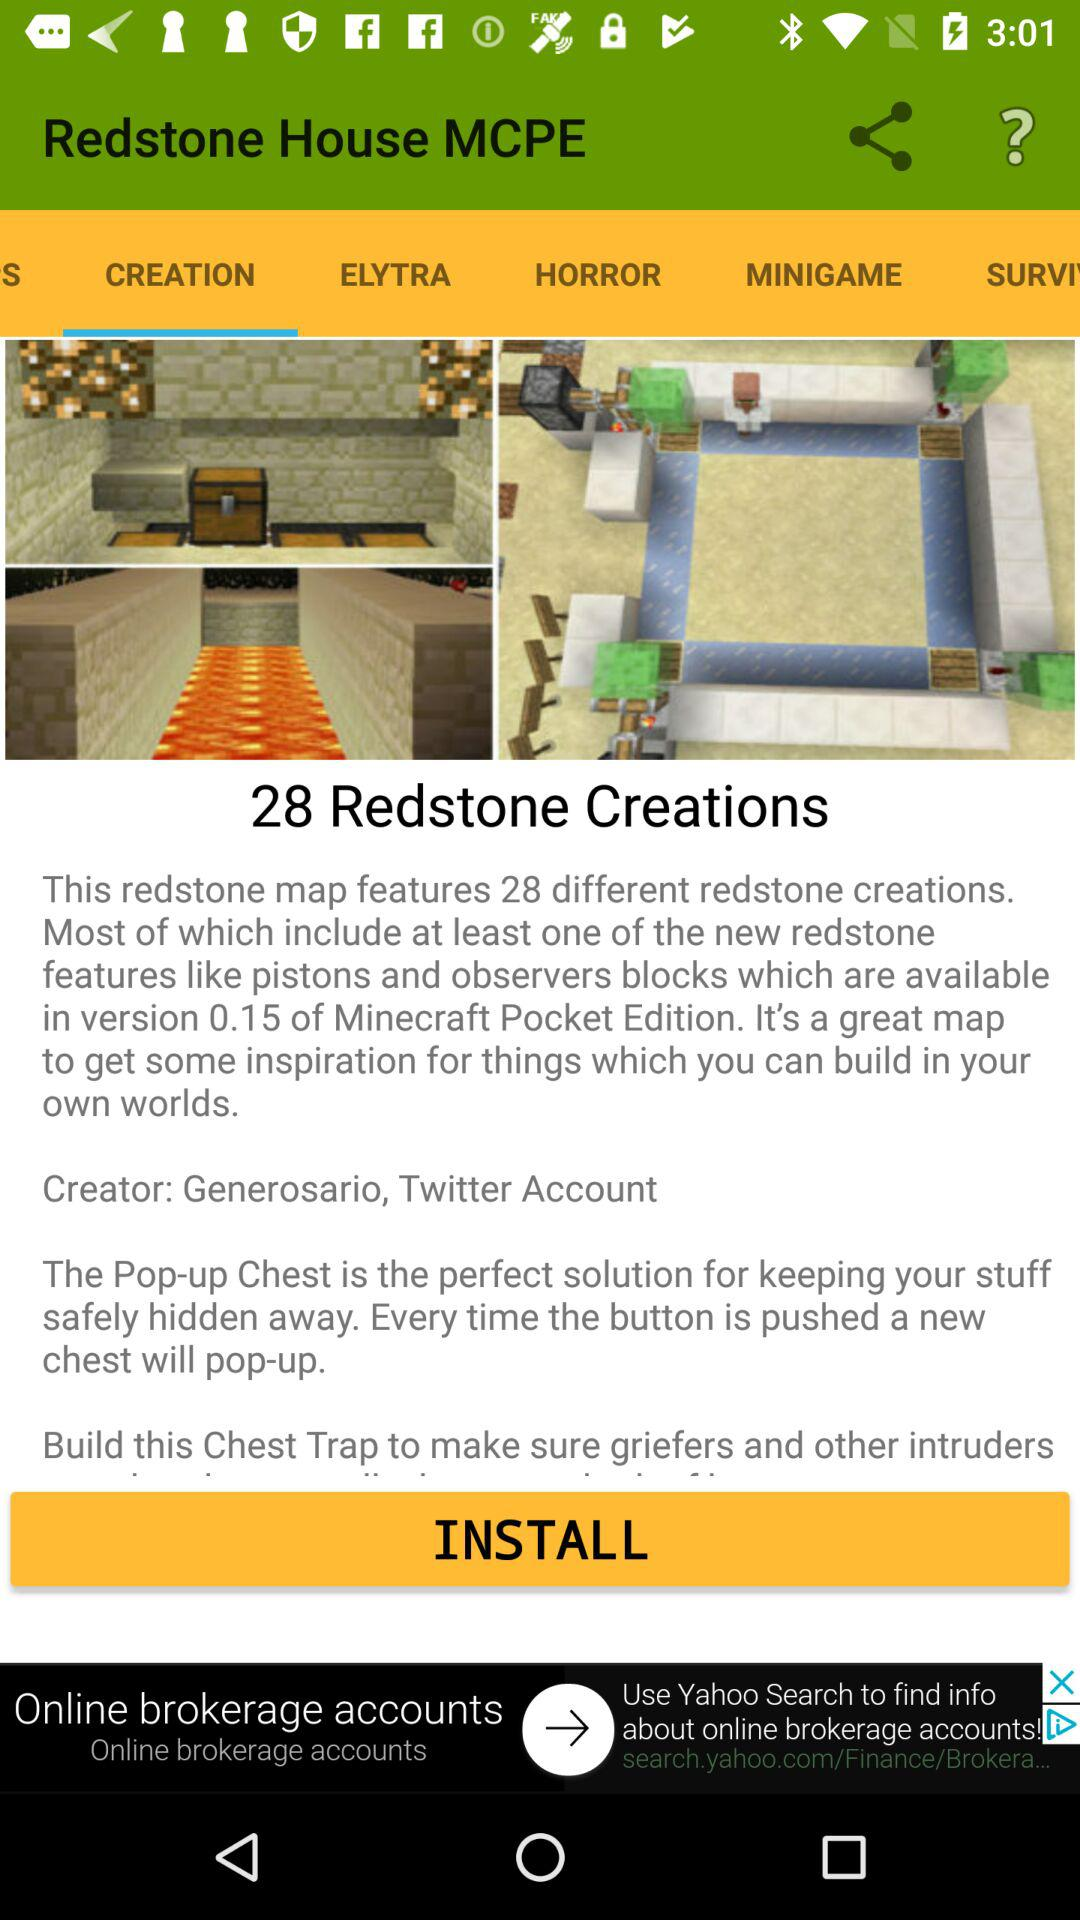Who is the creator of this creation? The creator is "Generosario, Twitter Account". 